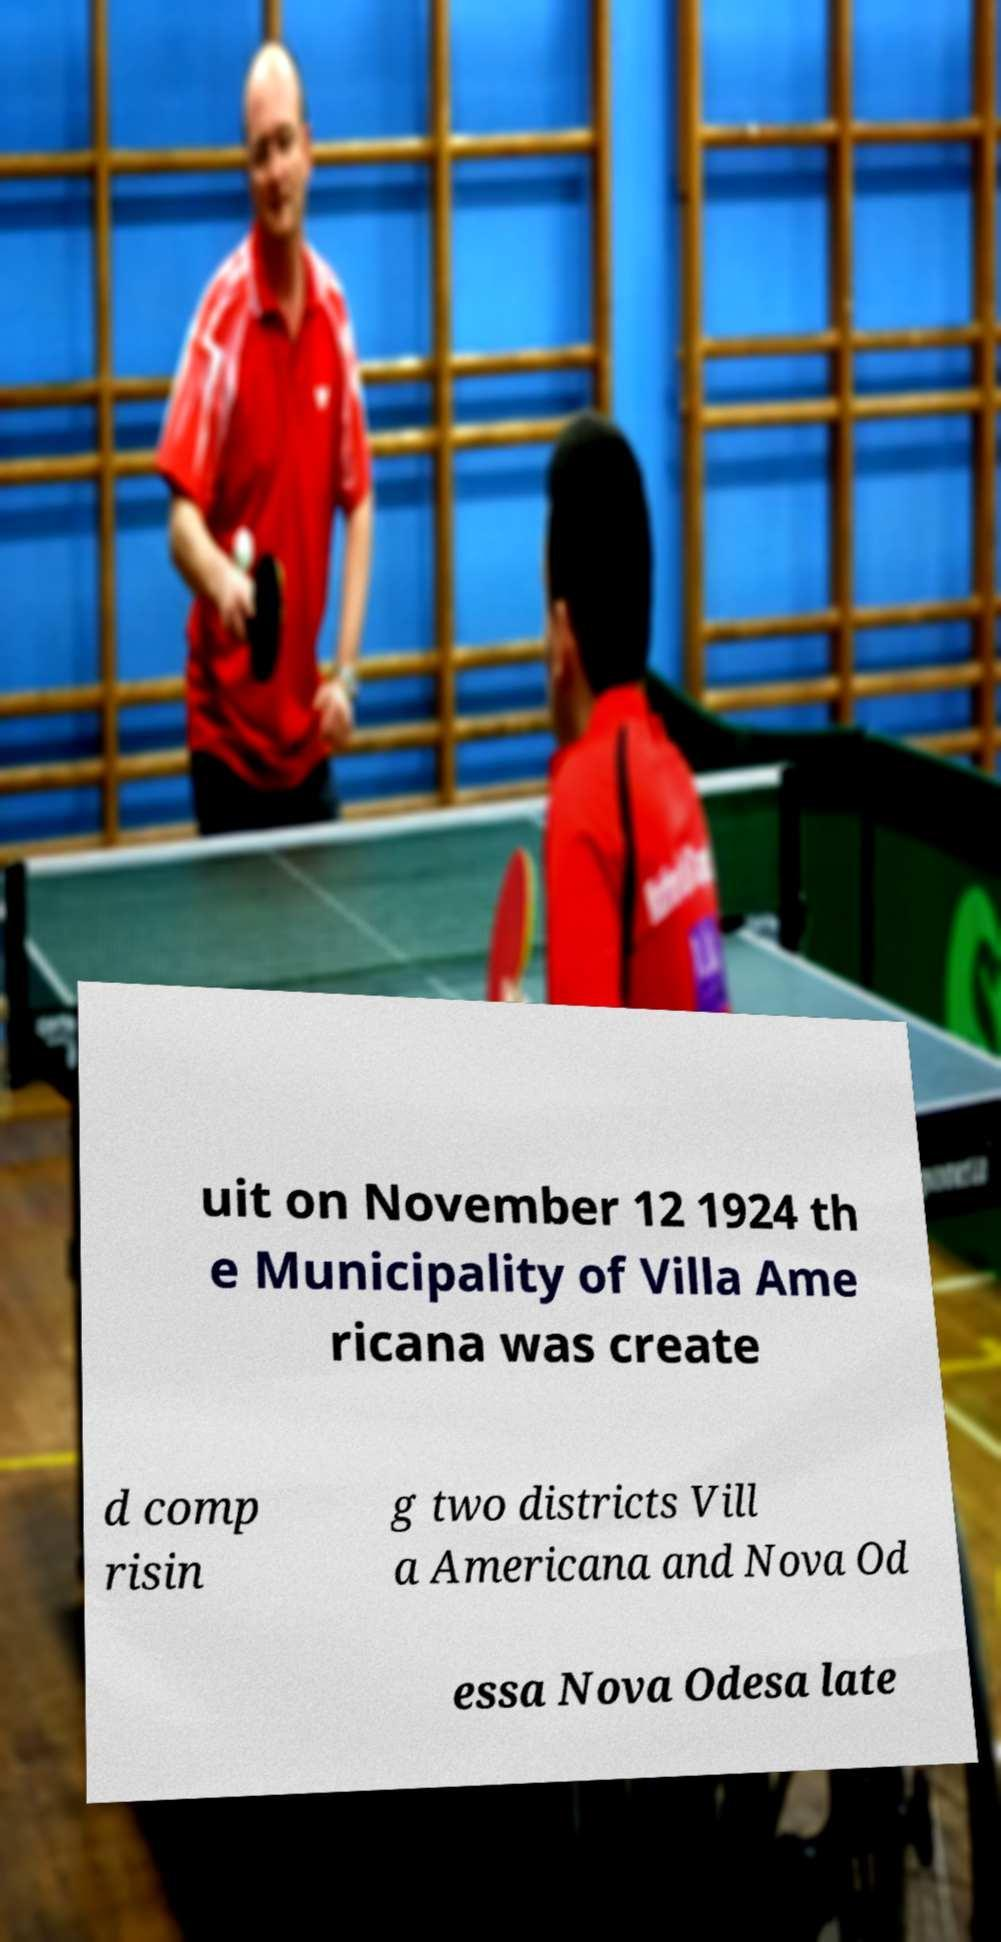I need the written content from this picture converted into text. Can you do that? uit on November 12 1924 th e Municipality of Villa Ame ricana was create d comp risin g two districts Vill a Americana and Nova Od essa Nova Odesa late 